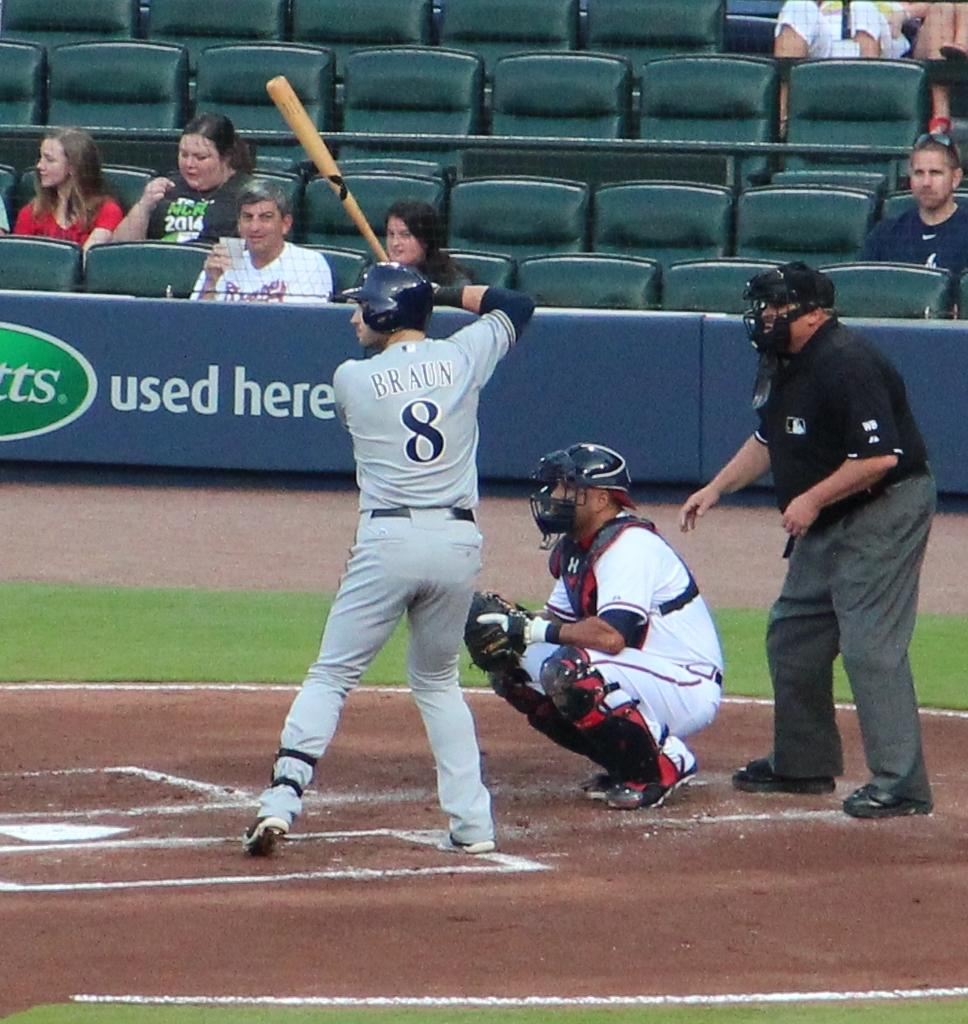Provide a one-sentence caption for the provided image. Baseball player Braun prepares to swing and hit a pitch during a baseball game. 